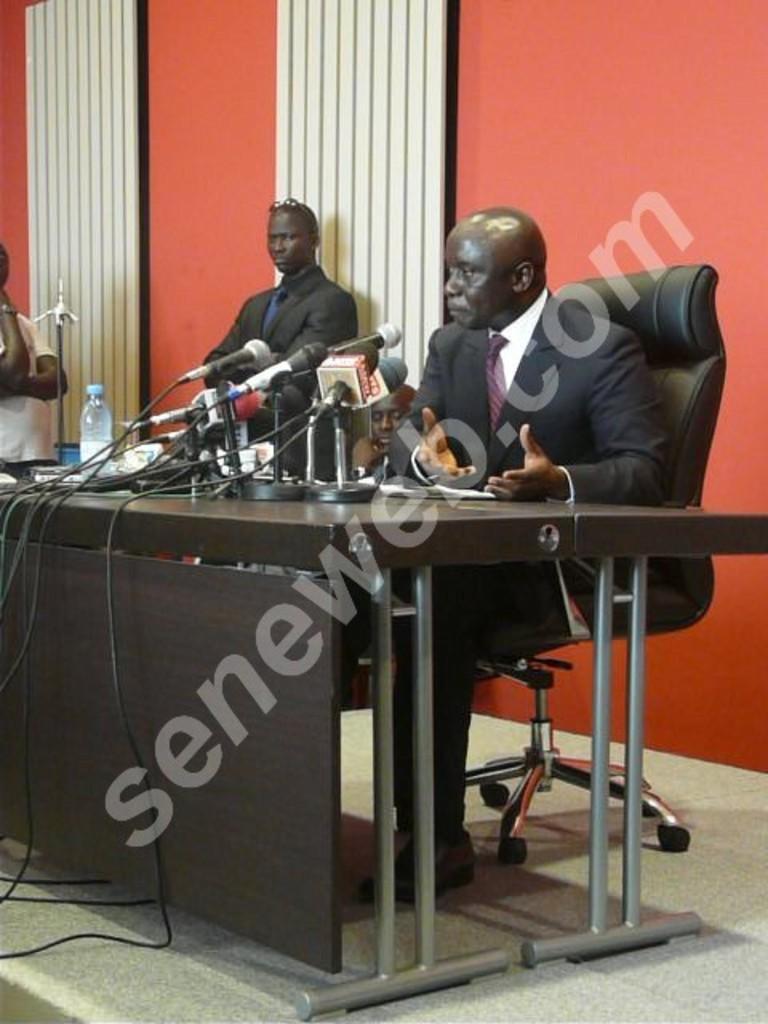Could you give a brief overview of what you see in this image? In this image I see a man who is sitting on the chair and he is wearing a suit, I can also see there is a table in front and there are lot of mics and a bottle on it. In the background I see 2 men and the wall 